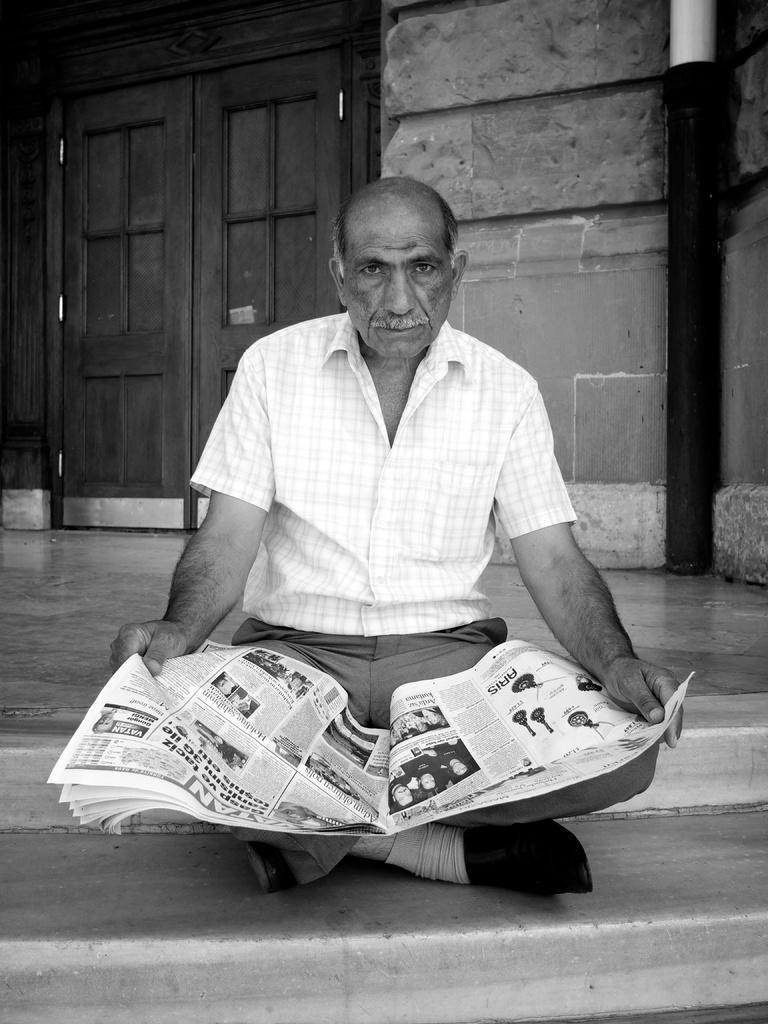Please provide a concise description of this image. This is a black and white image. In this image we can see there is a person sitting on the stairs and holding a newspaper, back of him there is a door of a building. 